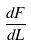<formula> <loc_0><loc_0><loc_500><loc_500>\frac { d F } { d L }</formula> 